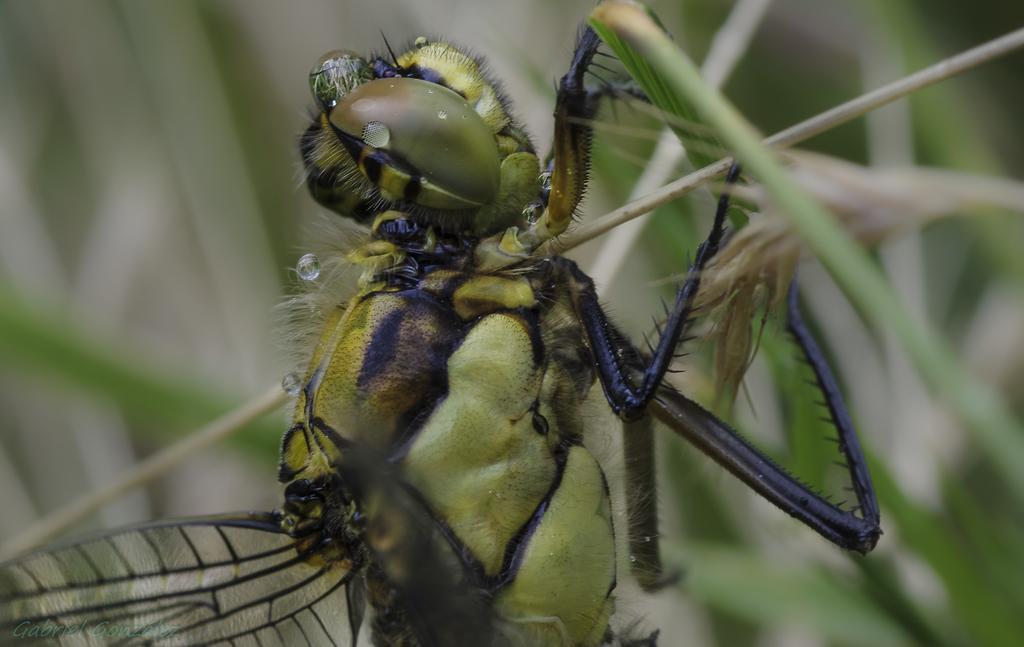In one or two sentences, can you explain what this image depicts? In the picture we can see an insect which is green in color with eyes, legs and wings and it is sitting on the plants. 